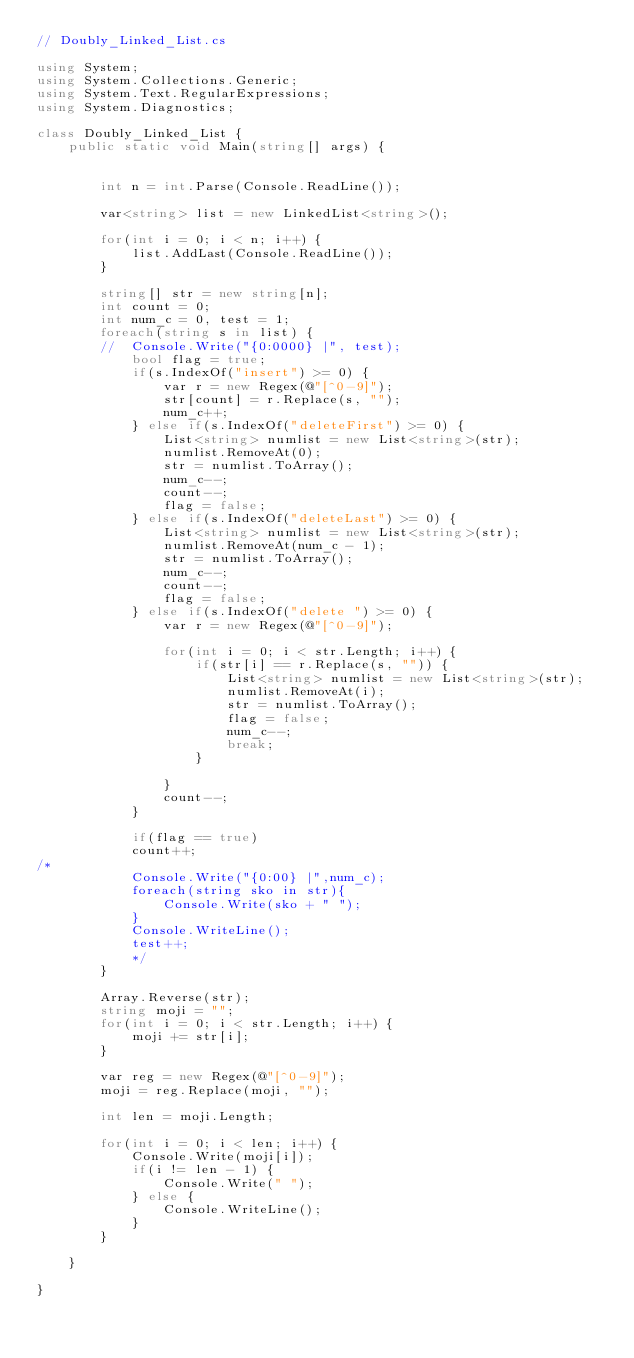<code> <loc_0><loc_0><loc_500><loc_500><_C#_>// Doubly_Linked_List.cs

using System;
using System.Collections.Generic;
using System.Text.RegularExpressions;
using System.Diagnostics;

class Doubly_Linked_List {
	public static void Main(string[] args) {


		int n = int.Parse(Console.ReadLine());

		var<string> list = new LinkedList<string>();

		for(int i = 0; i < n; i++) {
			list.AddLast(Console.ReadLine());
		}

		string[] str = new string[n];
		int count = 0;
		int num_c = 0, test = 1;
		foreach(string s in list) {
		//	Console.Write("{0:0000} |", test);
			bool flag = true;
			if(s.IndexOf("insert") >= 0) {
				var r = new Regex(@"[^0-9]");
				str[count] = r.Replace(s, "");
				num_c++;
			} else if(s.IndexOf("deleteFirst") >= 0) {
				List<string> numlist = new List<string>(str);
				numlist.RemoveAt(0);
				str = numlist.ToArray();
				num_c--;
				count--;
				flag = false;
			} else if(s.IndexOf("deleteLast") >= 0) {
				List<string> numlist = new List<string>(str);
				numlist.RemoveAt(num_c - 1);
				str = numlist.ToArray();
				num_c--;
				count--;
				flag = false;
			} else if(s.IndexOf("delete ") >= 0) {
				var r = new Regex(@"[^0-9]");

				for(int i = 0; i < str.Length; i++) {
					if(str[i] == r.Replace(s, "")) {
						List<string> numlist = new List<string>(str);
						numlist.RemoveAt(i);
						str = numlist.ToArray();
						flag = false;
						num_c--;
						break;
					}

				}
				count--;
			}

			if(flag == true)
			count++;
/*
			Console.Write("{0:00} |",num_c);
			foreach(string sko in str){
				Console.Write(sko + " ");
			}
			Console.WriteLine();
			test++;
			*/
		}

		Array.Reverse(str);
		string moji = "";
		for(int i = 0; i < str.Length; i++) {
			moji += str[i];
		}

		var reg = new Regex(@"[^0-9]");
		moji = reg.Replace(moji, "");

		int len = moji.Length;

		for(int i = 0; i < len; i++) {
			Console.Write(moji[i]);
			if(i != len - 1) {
				Console.Write(" ");
			} else {
				Console.WriteLine();
			}
		}

	}

}</code> 